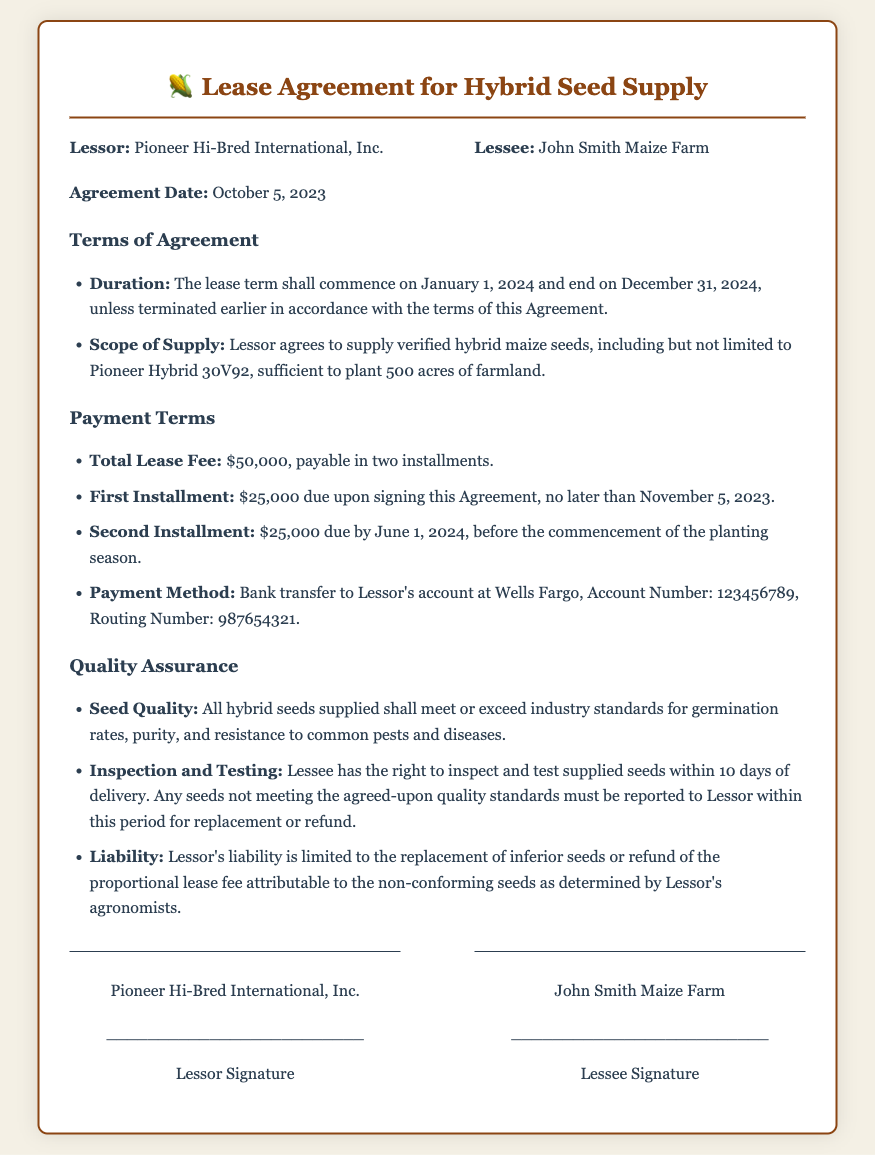What is the name of the lessor? The lessor is identified in the document as Pioneer Hi-Bred International, Inc.
Answer: Pioneer Hi-Bred International, Inc What is the total lease fee? The total lease fee is stated as $50,000 in the payment terms section.
Answer: $50,000 When is the second installment due? The second installment payment date is specified as June 1, 2024.
Answer: June 1, 2024 What is the duration of the lease? The lease term begins on January 1, 2024 and ends on December 31, 2024.
Answer: January 1, 2024 to December 31, 2024 What is the required payment method? The payment method outlined in the document is bank transfer to the Lessor's account at Wells Fargo.
Answer: Bank transfer What is the seed quality requirement? The document specifies that all hybrid seeds must meet or exceed industry standards for germination rates, purity, and resistance.
Answer: Industry standards What happens if supplied seeds do not meet quality standards? The document states that any seeds not meeting quality standards must be reported to the Lessor within 10 days for replacement or refund.
Answer: Replacement or refund What is the liability of the lessor regarding inferior seeds? The lessor's liability is limited to the replacement of inferior seeds or refund of the proportional lease fee as determined by agronomists.
Answer: Replacement or refund Who is the lessee? The lessee is identified as John Smith Maize Farm in the document.
Answer: John Smith Maize Farm 